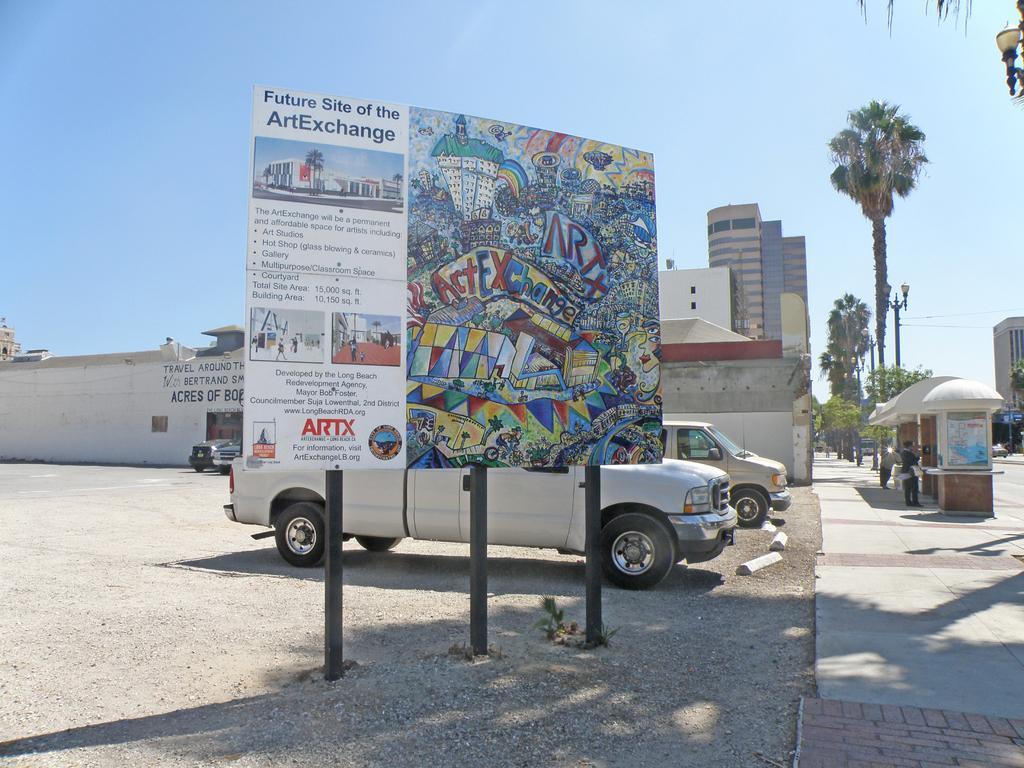How would you summarize this image in a sentence or two? In the foreground I can see a board, pillars, vehicles on the road and two persons. In the background I can see buildings, trees, light poles, wires and the sky. This image is taken may be during a day. 